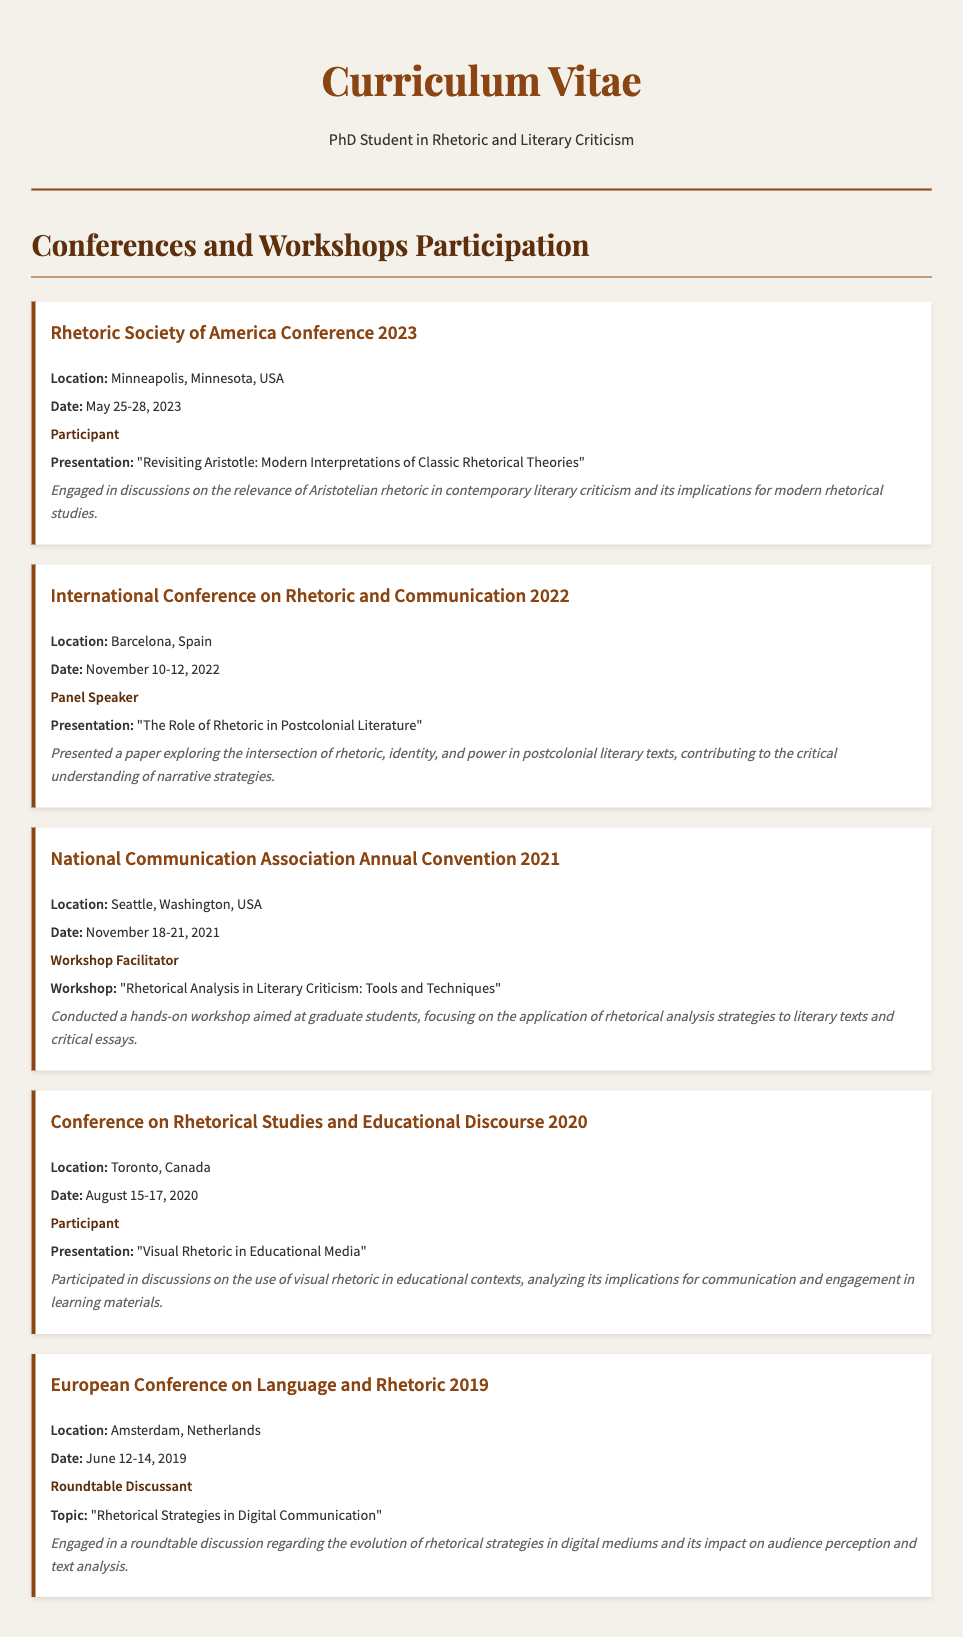what is the location of the Rhetoric Society of America Conference 2023? The location of the conference is explicitly stated in the document as Minneapolis, Minnesota, USA.
Answer: Minneapolis, Minnesota, USA what was the presentation title at the International Conference on Rhetoric and Communication 2022? The title of the presentation is found in the entry for the 2022 conference.
Answer: The Role of Rhetoric in Postcolonial Literature what is the date of the National Communication Association Annual Convention 2021? The dates of the convention are listed under that specific conference entry.
Answer: November 18-21, 2021 who was the workshop facilitator at the National Communication Association Annual Convention 2021? The role of the individual at the 2021 convention is provided under that conference section in the document.
Answer: Workshop Facilitator how many conferences and workshops are listed in total? The total count can be derived from the number of conference entries presented in the document.
Answer: 5 what recurring theme is evident in the presentations listed? To determine this, one must analyze the topics and discussions across the conferences, particularly focusing on rhetoric's application in various contexts.
Answer: Rhetoric what type of role did the individual have at the European Conference on Language and Rhetoric 2019? The role is clearly specified under the entry for the 2019 conference.
Answer: Roundtable Discussant what subject was explored in the workshop conducted at the National Communication Association Annual Convention 2021? The workshop topic is explicitly detailed in the relevant conference entry.
Answer: Rhetorical Analysis in Literary Criticism: Tools and Techniques which presentation discussed visual rhetoric? The document contains a specific entry that mentions this focus in its description.
Answer: Visual Rhetoric in Educational Media where was the European Conference on Language and Rhetoric 2019 held? The location of the conference can be found within that entry in the document.
Answer: Amsterdam, Netherlands 